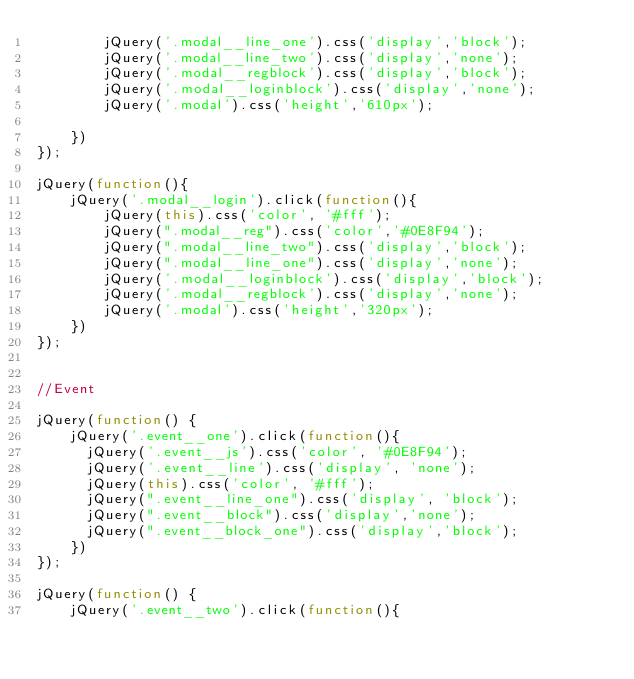<code> <loc_0><loc_0><loc_500><loc_500><_JavaScript_>        jQuery('.modal__line_one').css('display','block');
        jQuery('.modal__line_two').css('display','none');
        jQuery('.modal__regblock').css('display','block');
        jQuery('.modal__loginblock').css('display','none');
        jQuery('.modal').css('height','610px');

    })
});

jQuery(function(){
    jQuery('.modal__login').click(function(){
        jQuery(this).css('color', '#fff');
        jQuery(".modal__reg").css('color','#0E8F94');
        jQuery(".modal__line_two").css('display','block');
        jQuery(".modal__line_one").css('display','none');
        jQuery('.modal__loginblock').css('display','block');
        jQuery('.modal__regblock').css('display','none');
        jQuery('.modal').css('height','320px');
    })
});


//Event

jQuery(function() {
    jQuery('.event__one').click(function(){
    	jQuery('.event__js').css('color', '#0E8F94');
    	jQuery('.event__line').css('display', 'none');
    	jQuery(this).css('color', '#fff');
    	jQuery(".event__line_one").css('display', 'block');
    	jQuery(".event__block").css('display','none');
    	jQuery(".event__block_one").css('display','block');
    })
});

jQuery(function() {
    jQuery('.event__two').click(function(){</code> 